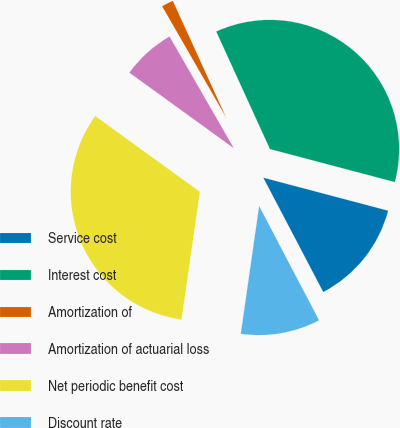Convert chart to OTSL. <chart><loc_0><loc_0><loc_500><loc_500><pie_chart><fcel>Service cost<fcel>Interest cost<fcel>Amortization of<fcel>Amortization of actuarial loss<fcel>Net periodic benefit cost<fcel>Discount rate<nl><fcel>13.2%<fcel>35.94%<fcel>1.49%<fcel>6.72%<fcel>32.7%<fcel>9.96%<nl></chart> 